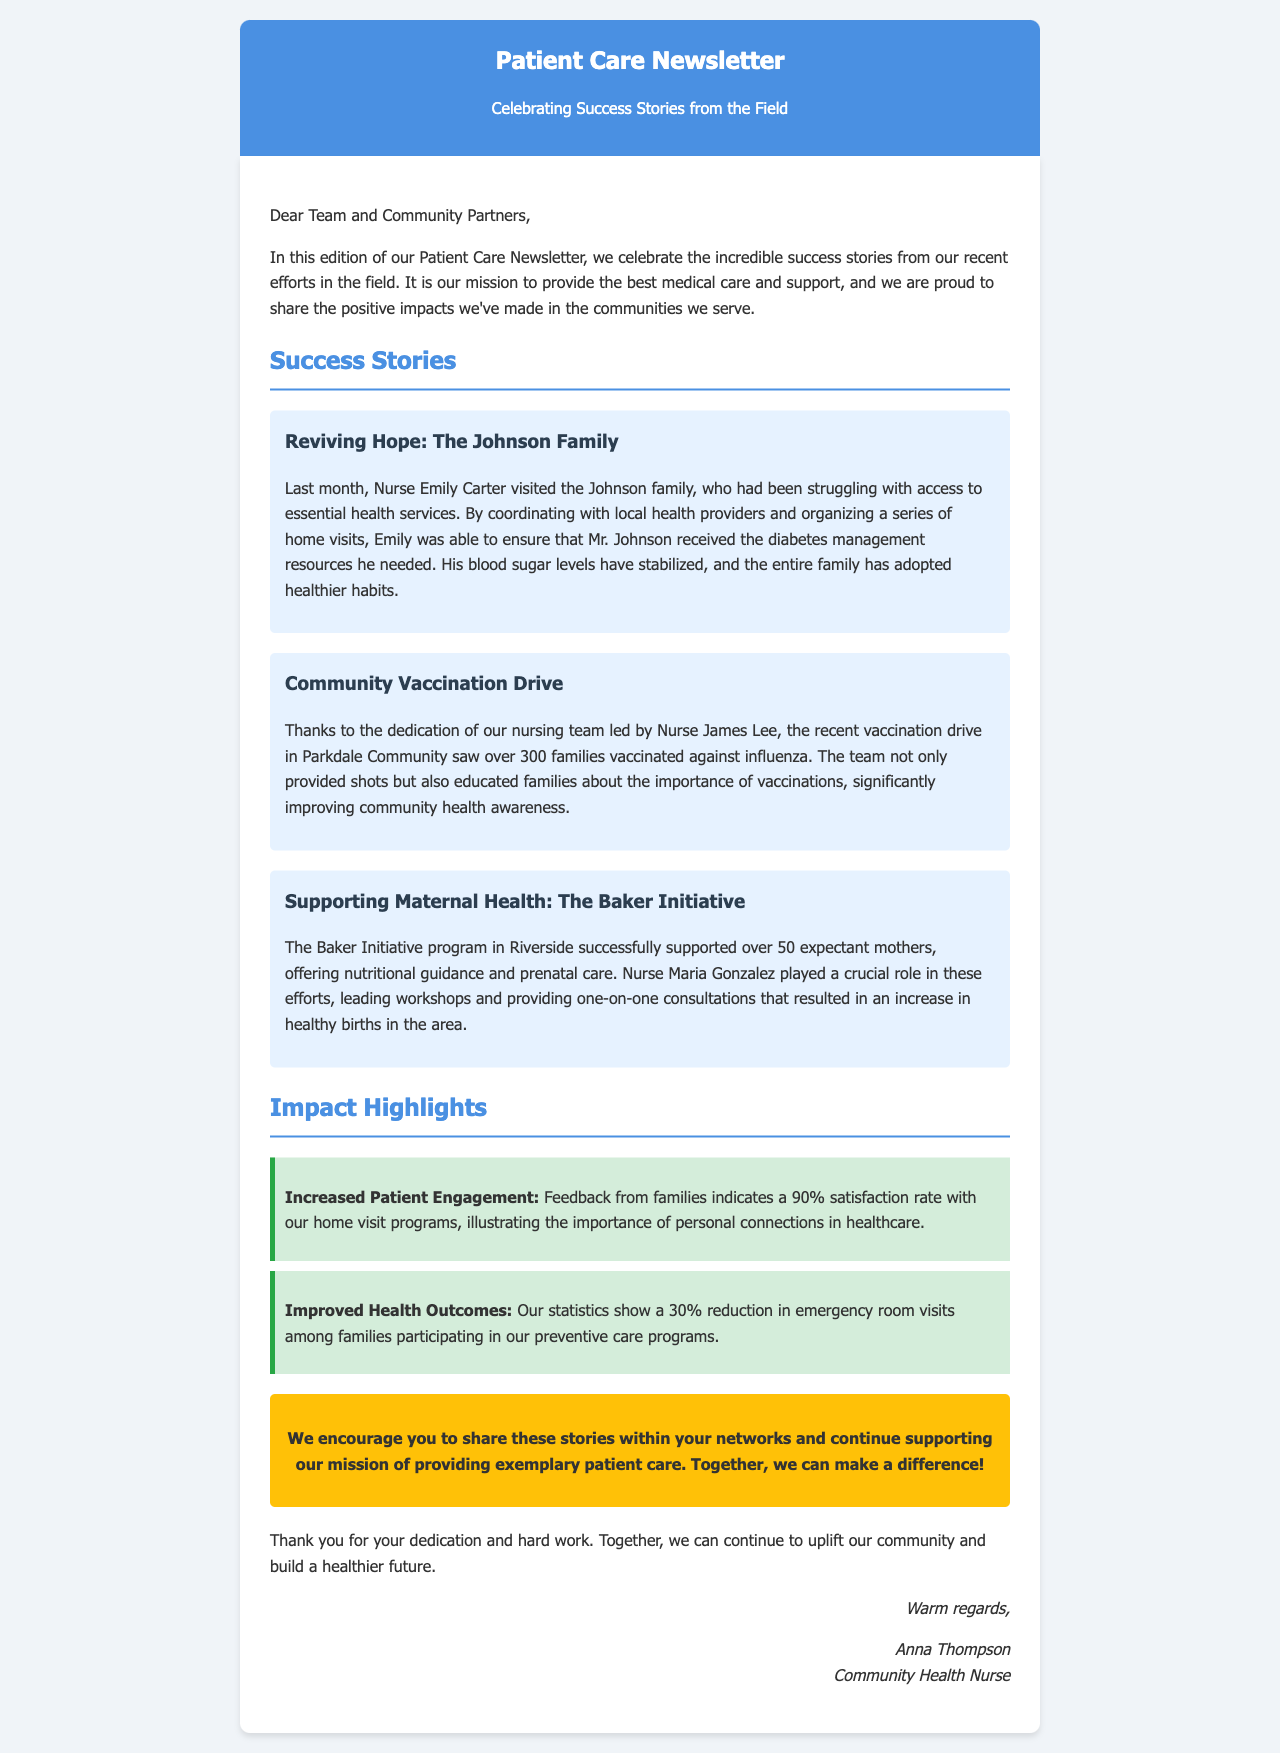What is the title of the newsletter? The title of the newsletter is presented prominently at the top of the document.
Answer: Patient Care Newsletter Who coordinated the health services for the Johnson family? The document specifies that Nurse Emily Carter was responsible for coordinating the health services for the Johnson family.
Answer: Emily Carter How many families were vaccinated during the Parkdale Community vaccination drive? The document states that over 300 families were vaccinated during the vaccination drive.
Answer: 300 What was the satisfaction rate with the home visit programs? The newsletter mentions a specific percentage reflecting family satisfaction with home visit programs.
Answer: 90% Which nurse led the Baker Initiative program? Based on the information provided in the document, Nurse Maria Gonzalez led the Baker Initiative program.
Answer: Maria Gonzalez What percentage reduction in emergency room visits was reported? The document provides a specific percentage indicating the reduction in emergency room visits for participating families.
Answer: 30% What type of guidance was offered to expectant mothers in the Baker Initiative? The program specifically focused on one type of support that was essential for the mothers involved.
Answer: Nutritional guidance What color is used for the newsletter's header? The document describes the color used for the header section of the newsletter.
Answer: Blue 